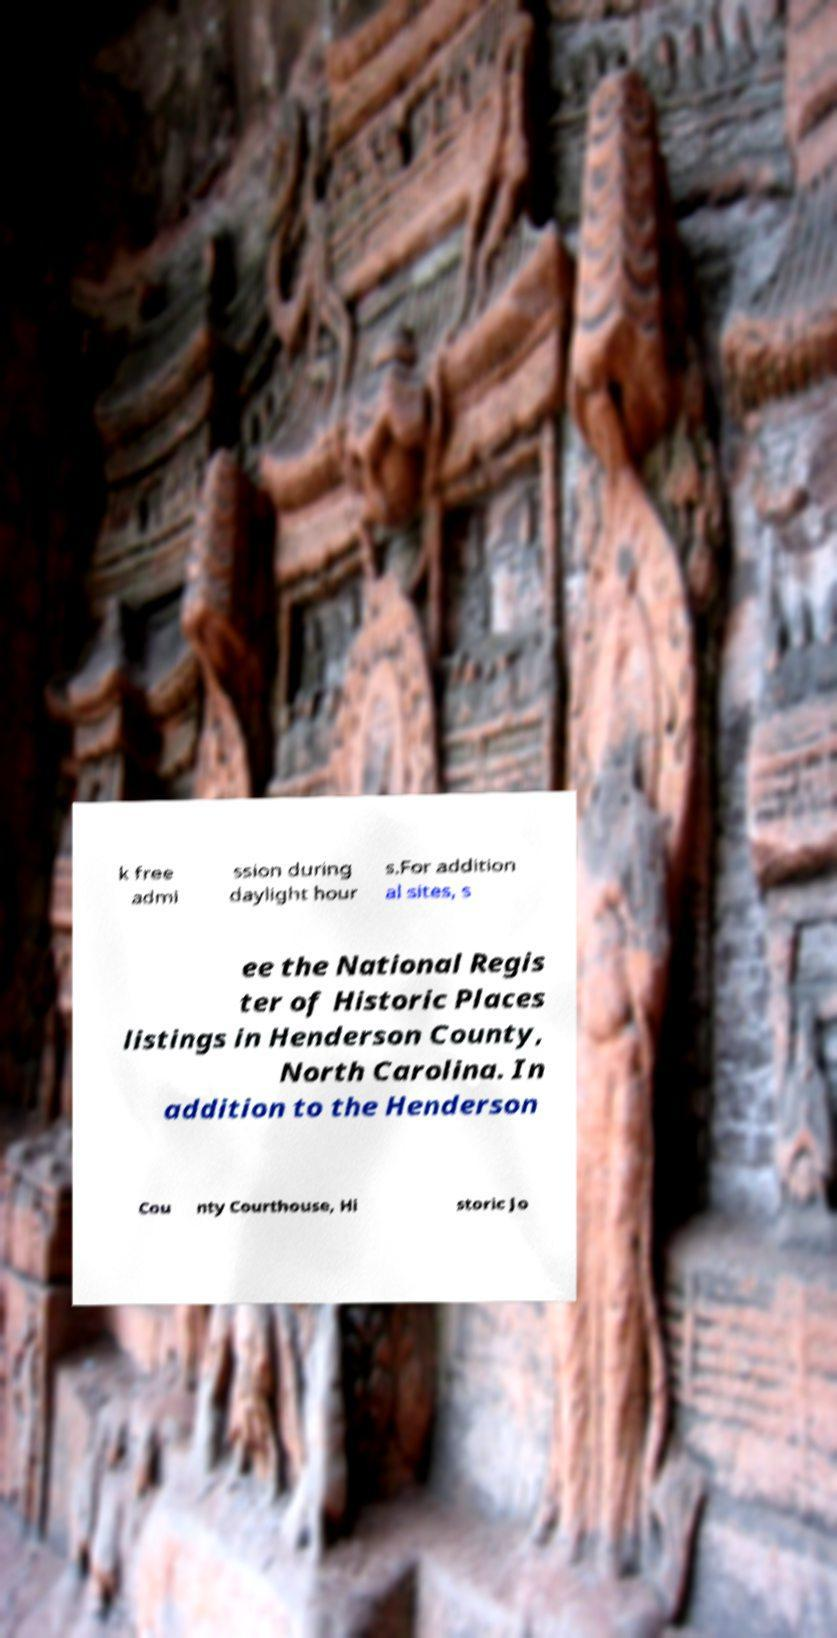For documentation purposes, I need the text within this image transcribed. Could you provide that? k free admi ssion during daylight hour s.For addition al sites, s ee the National Regis ter of Historic Places listings in Henderson County, North Carolina. In addition to the Henderson Cou nty Courthouse, Hi storic Jo 